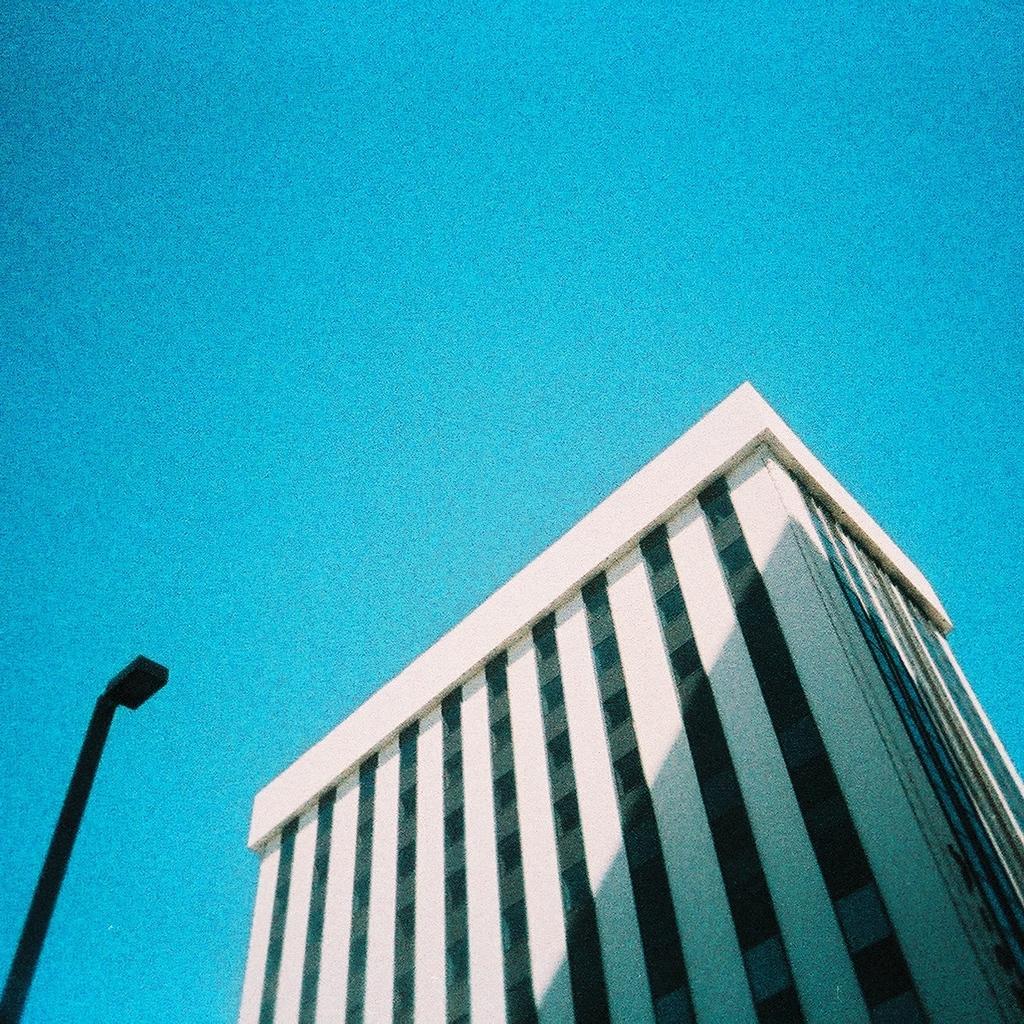Can you describe this image briefly? This image consists of a building in white color. On the left, there is a pole in black color. At the top, we can see the sky. 